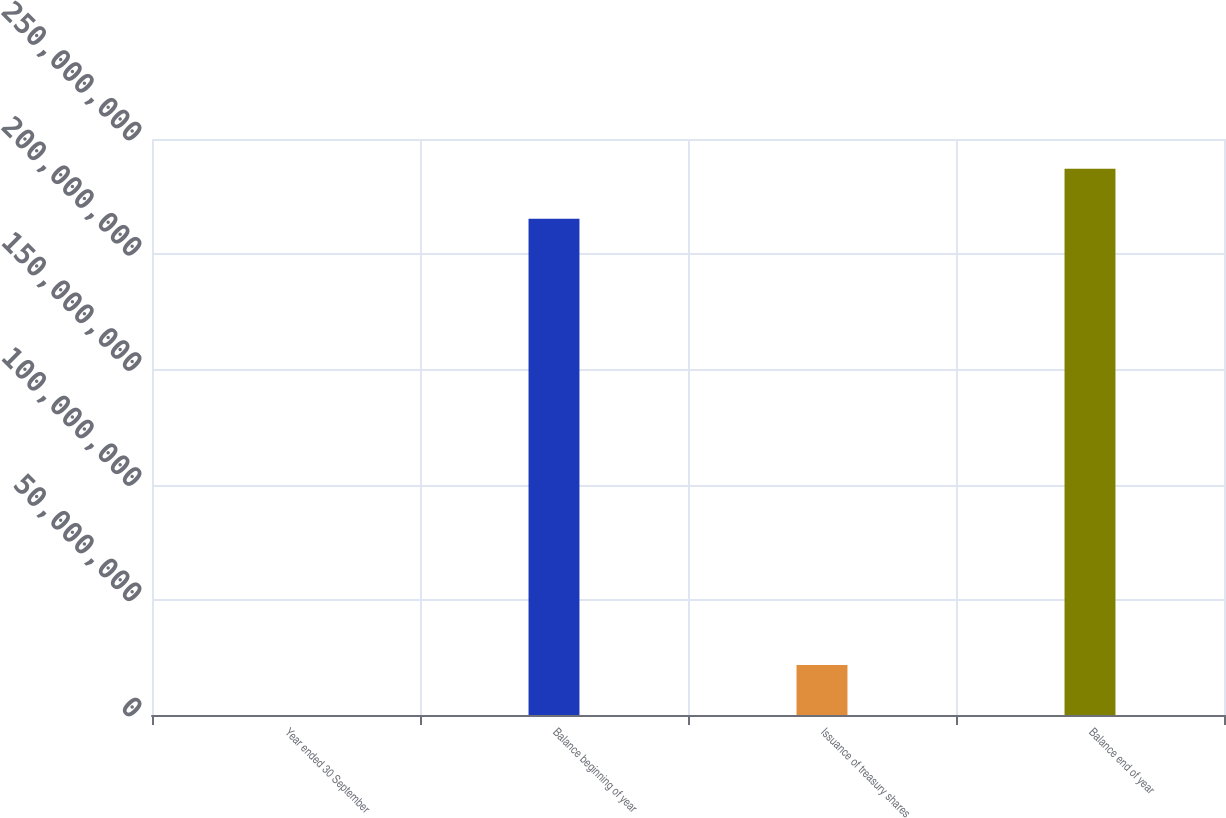<chart> <loc_0><loc_0><loc_500><loc_500><bar_chart><fcel>Year ended 30 September<fcel>Balance beginning of year<fcel>Issuance of treasury shares<fcel>Balance end of year<nl><fcel>2016<fcel>2.15359e+08<fcel>2.17369e+07<fcel>2.37094e+08<nl></chart> 